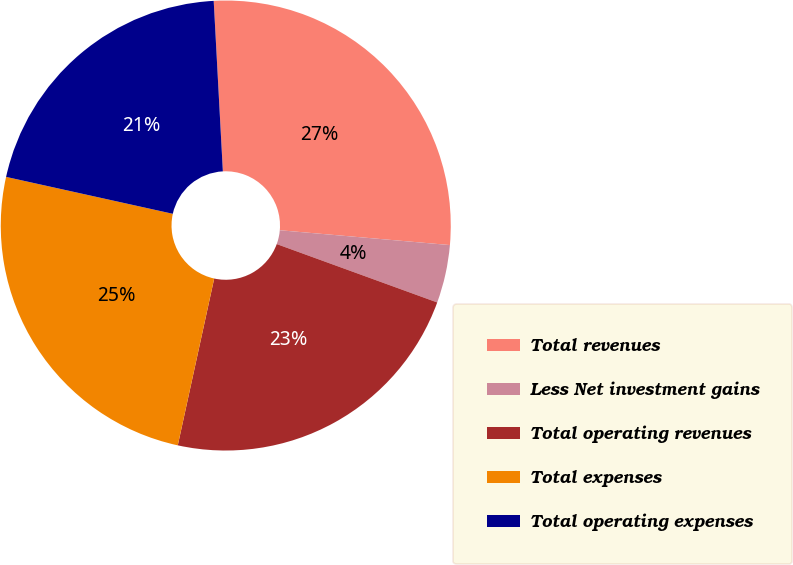<chart> <loc_0><loc_0><loc_500><loc_500><pie_chart><fcel>Total revenues<fcel>Less Net investment gains<fcel>Total operating revenues<fcel>Total expenses<fcel>Total operating expenses<nl><fcel>27.24%<fcel>4.17%<fcel>22.87%<fcel>25.05%<fcel>20.68%<nl></chart> 